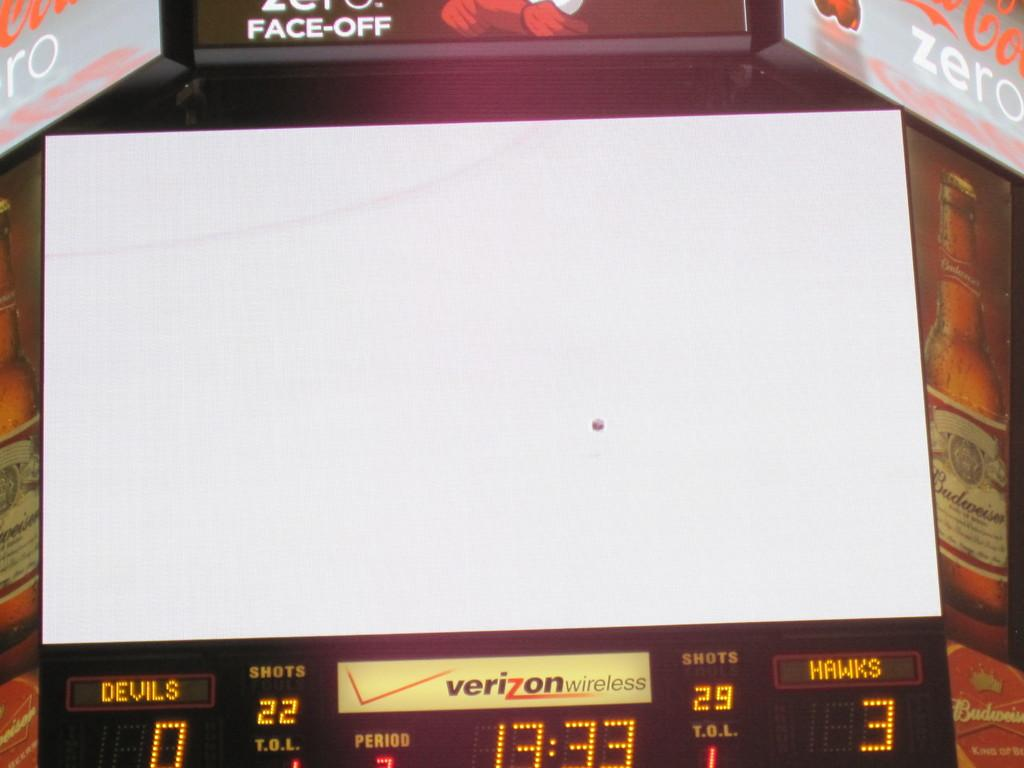Provide a one-sentence caption for the provided image. a timeclock for a basketball game at 13:33. 